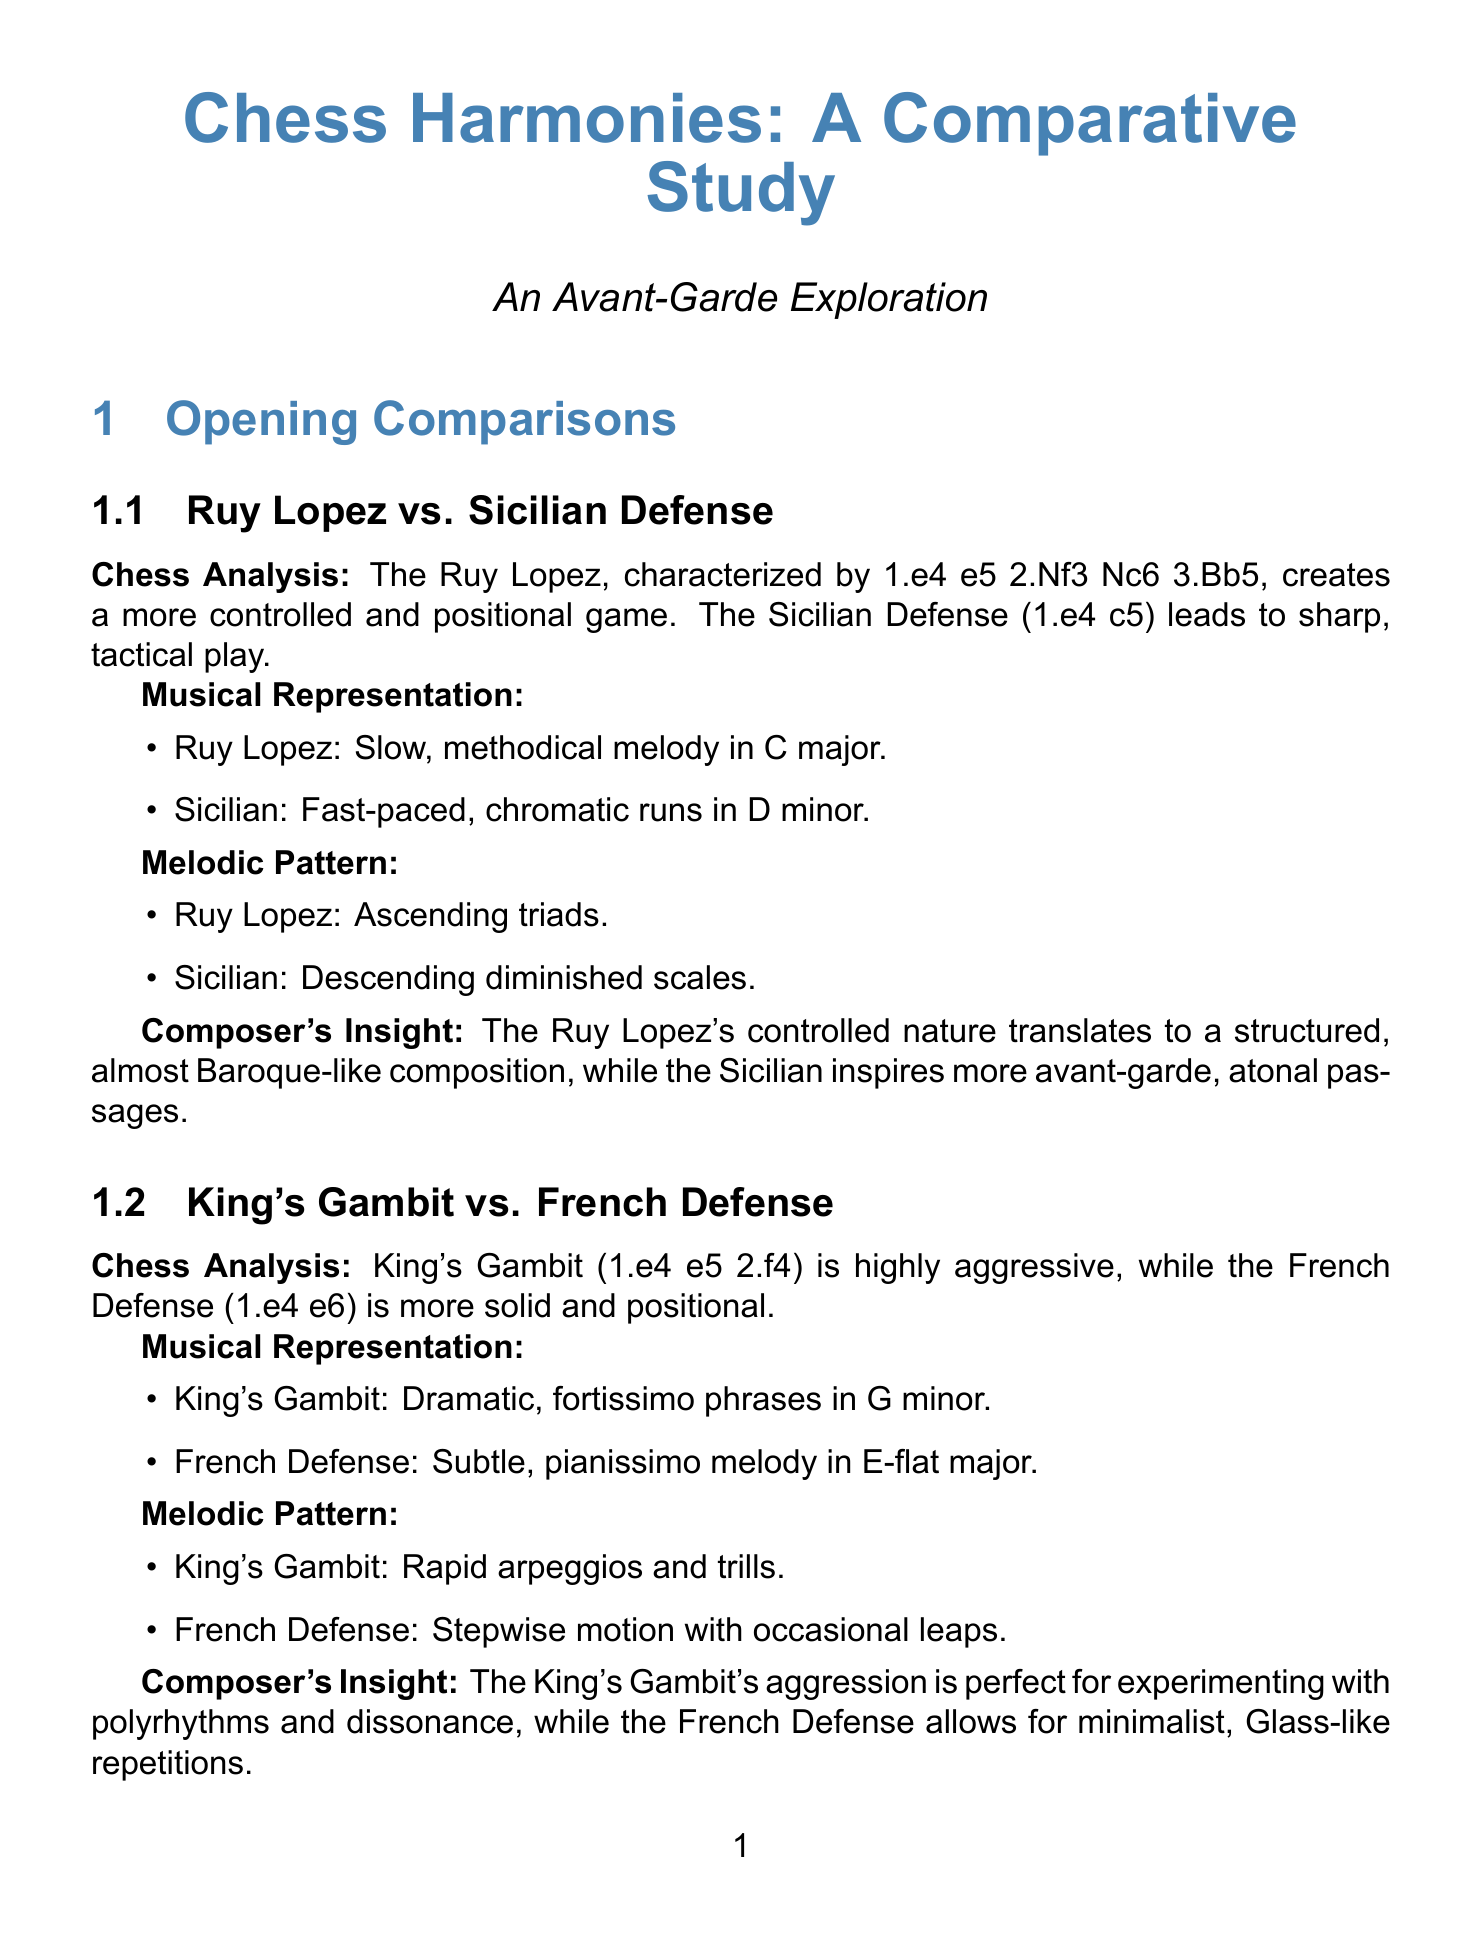What is the primary characteristic of the Ruy Lopez opening? The Ruy Lopez is characterized by 1.e4 e5 2.Nf3 Nc6 3.Bb5, creating a more controlled and positional game.
Answer: Controlled and positional game What musical key represents the King's Gambit? The King's Gambit is represented by dramatic, fortissimo phrases in G minor.
Answer: G minor Who composed "The Kasparov Variation"? John Cage composed "The Kasparov Variation."
Answer: John Cage What software is used for Chessboard Grid Notation? Max/MSP is the software used for Chessboard Grid Notation.
Answer: Max/MSP Which technique assigns unique instrument sounds to chess pieces? Piece-Specific Timbres is the technique that assigns unique instrument sounds to chess pieces.
Answer: Piece-Specific Timbres What year was "Echecs Sonores" composed? "Echecs Sonores" was composed in 1951.
Answer: 1951 What is the focus of the book "Chess Harmony: A Beginner's Guide"? The book teaches basic music theory and chess strategy in parallel.
Answer: Basic music theory and chess strategy Which AI system creates musical scores based on chess games? ChessMelody AI is the system that analyzes chess games and generates musical scores.
Answer: ChessMelody AI What is the website for ChessTone Academy? The website for ChessTone Academy is www.chesstoneacademy.com.
Answer: www.chestoneacademy.com 